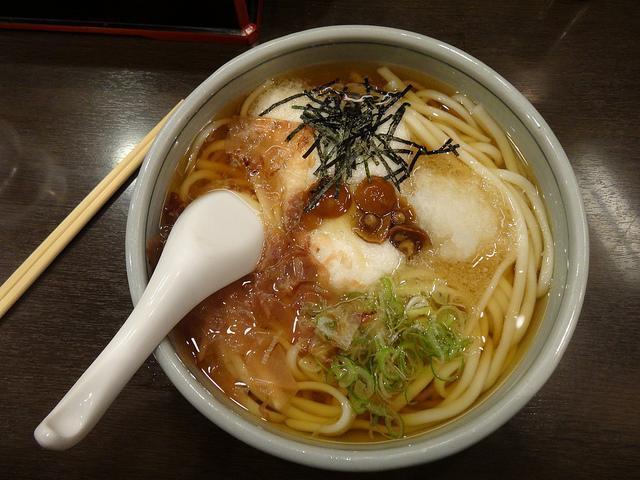How many train cars are under the poles?
Give a very brief answer. 0. 